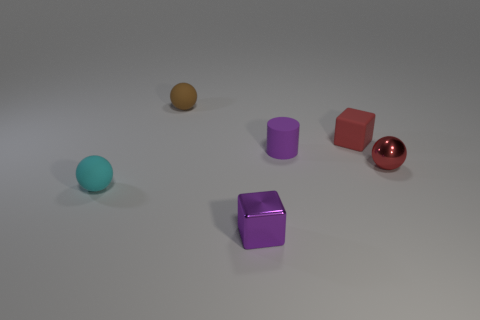If you had to guess, which object appears to be the heaviest? If we were to speculate based on their appearance, the red cube seems to be the heaviest object. Its size relative to the other items and the solid appearance suggest it has more mass, while the smaller objects, like the tiny cylinder or the balls, appear to be lighter. 